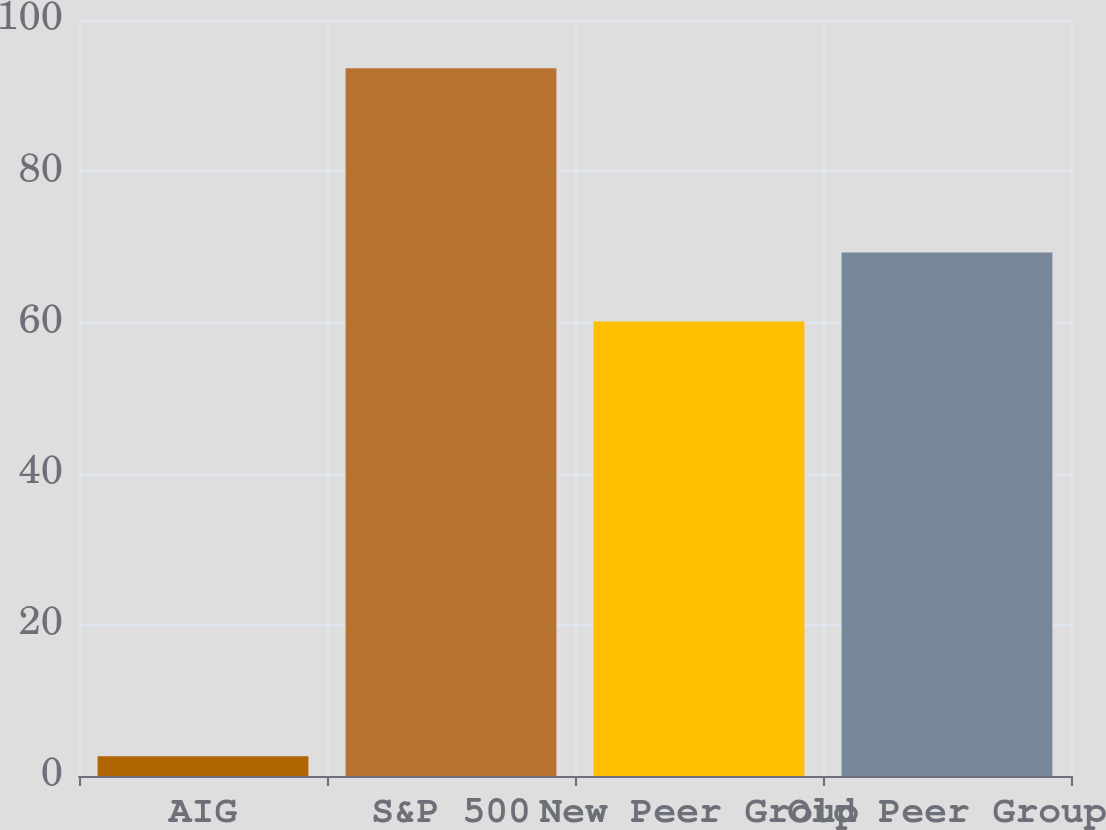<chart> <loc_0><loc_0><loc_500><loc_500><bar_chart><fcel>AIG<fcel>S&P 500<fcel>New Peer Group<fcel>Old Peer Group<nl><fcel>2.62<fcel>93.61<fcel>60.13<fcel>69.23<nl></chart> 